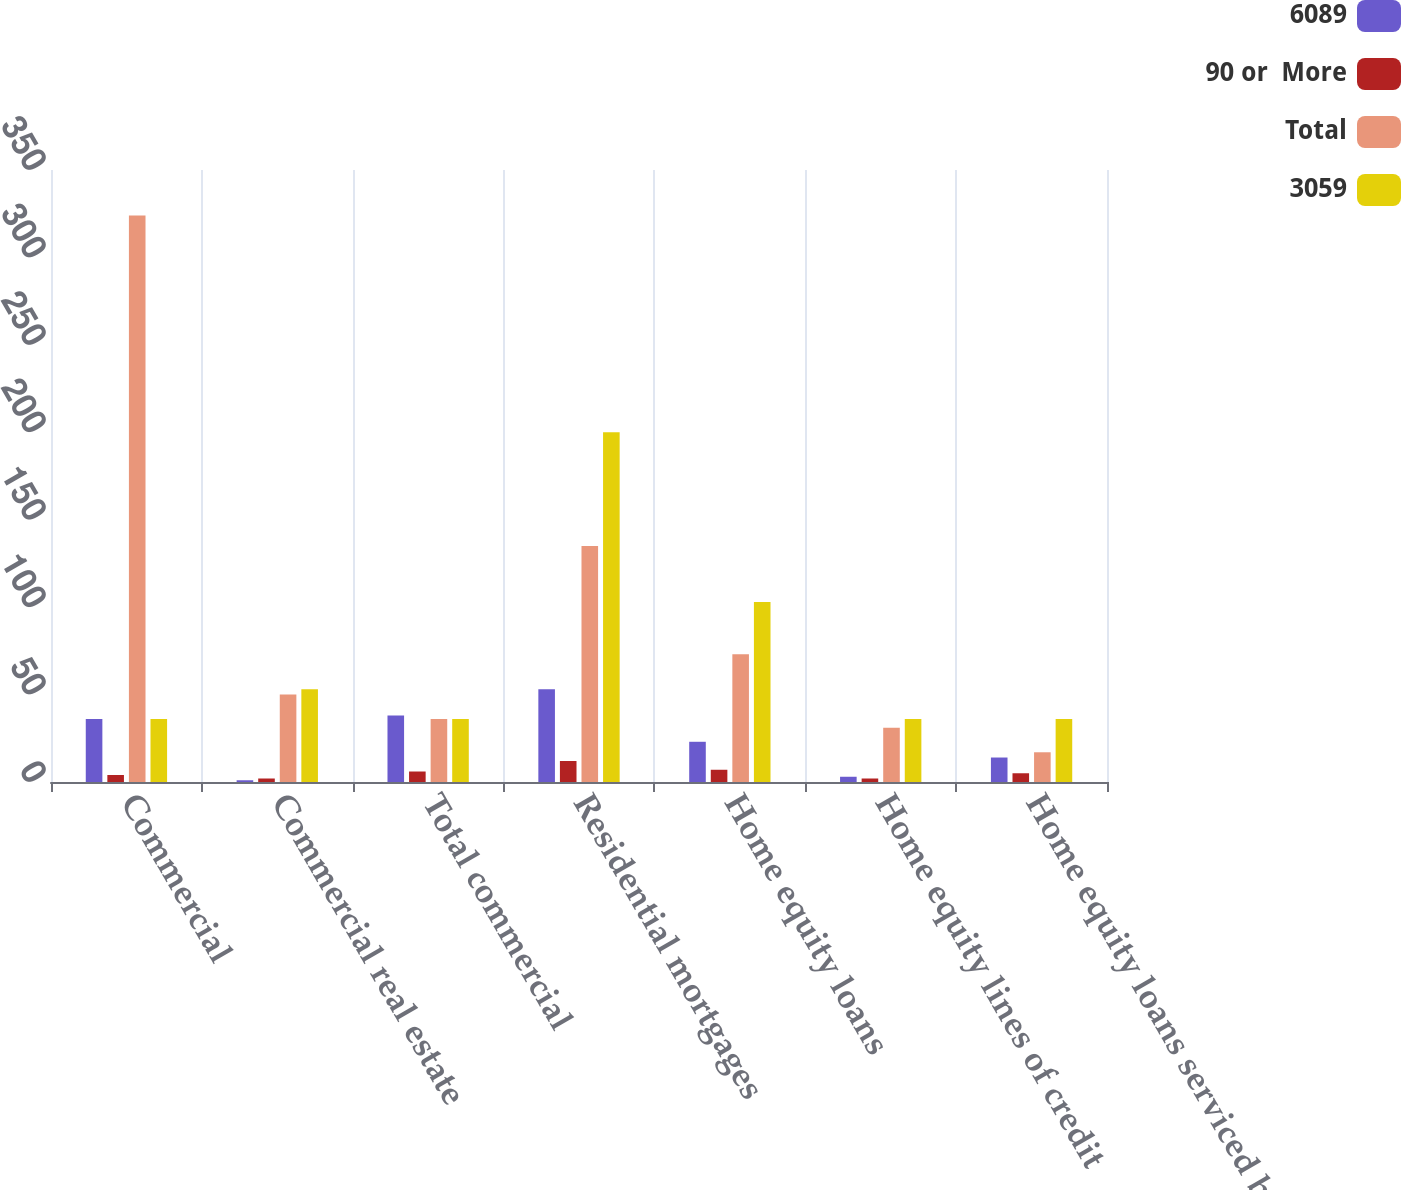Convert chart to OTSL. <chart><loc_0><loc_0><loc_500><loc_500><stacked_bar_chart><ecel><fcel>Commercial<fcel>Commercial real estate<fcel>Total commercial<fcel>Residential mortgages<fcel>Home equity loans<fcel>Home equity lines of credit<fcel>Home equity loans serviced by<nl><fcel>6089<fcel>36<fcel>1<fcel>38<fcel>53<fcel>23<fcel>3<fcel>14<nl><fcel>90 or  More<fcel>4<fcel>2<fcel>6<fcel>12<fcel>7<fcel>2<fcel>5<nl><fcel>Total<fcel>324<fcel>50<fcel>36<fcel>135<fcel>73<fcel>31<fcel>17<nl><fcel>3059<fcel>36<fcel>53<fcel>36<fcel>200<fcel>103<fcel>36<fcel>36<nl></chart> 